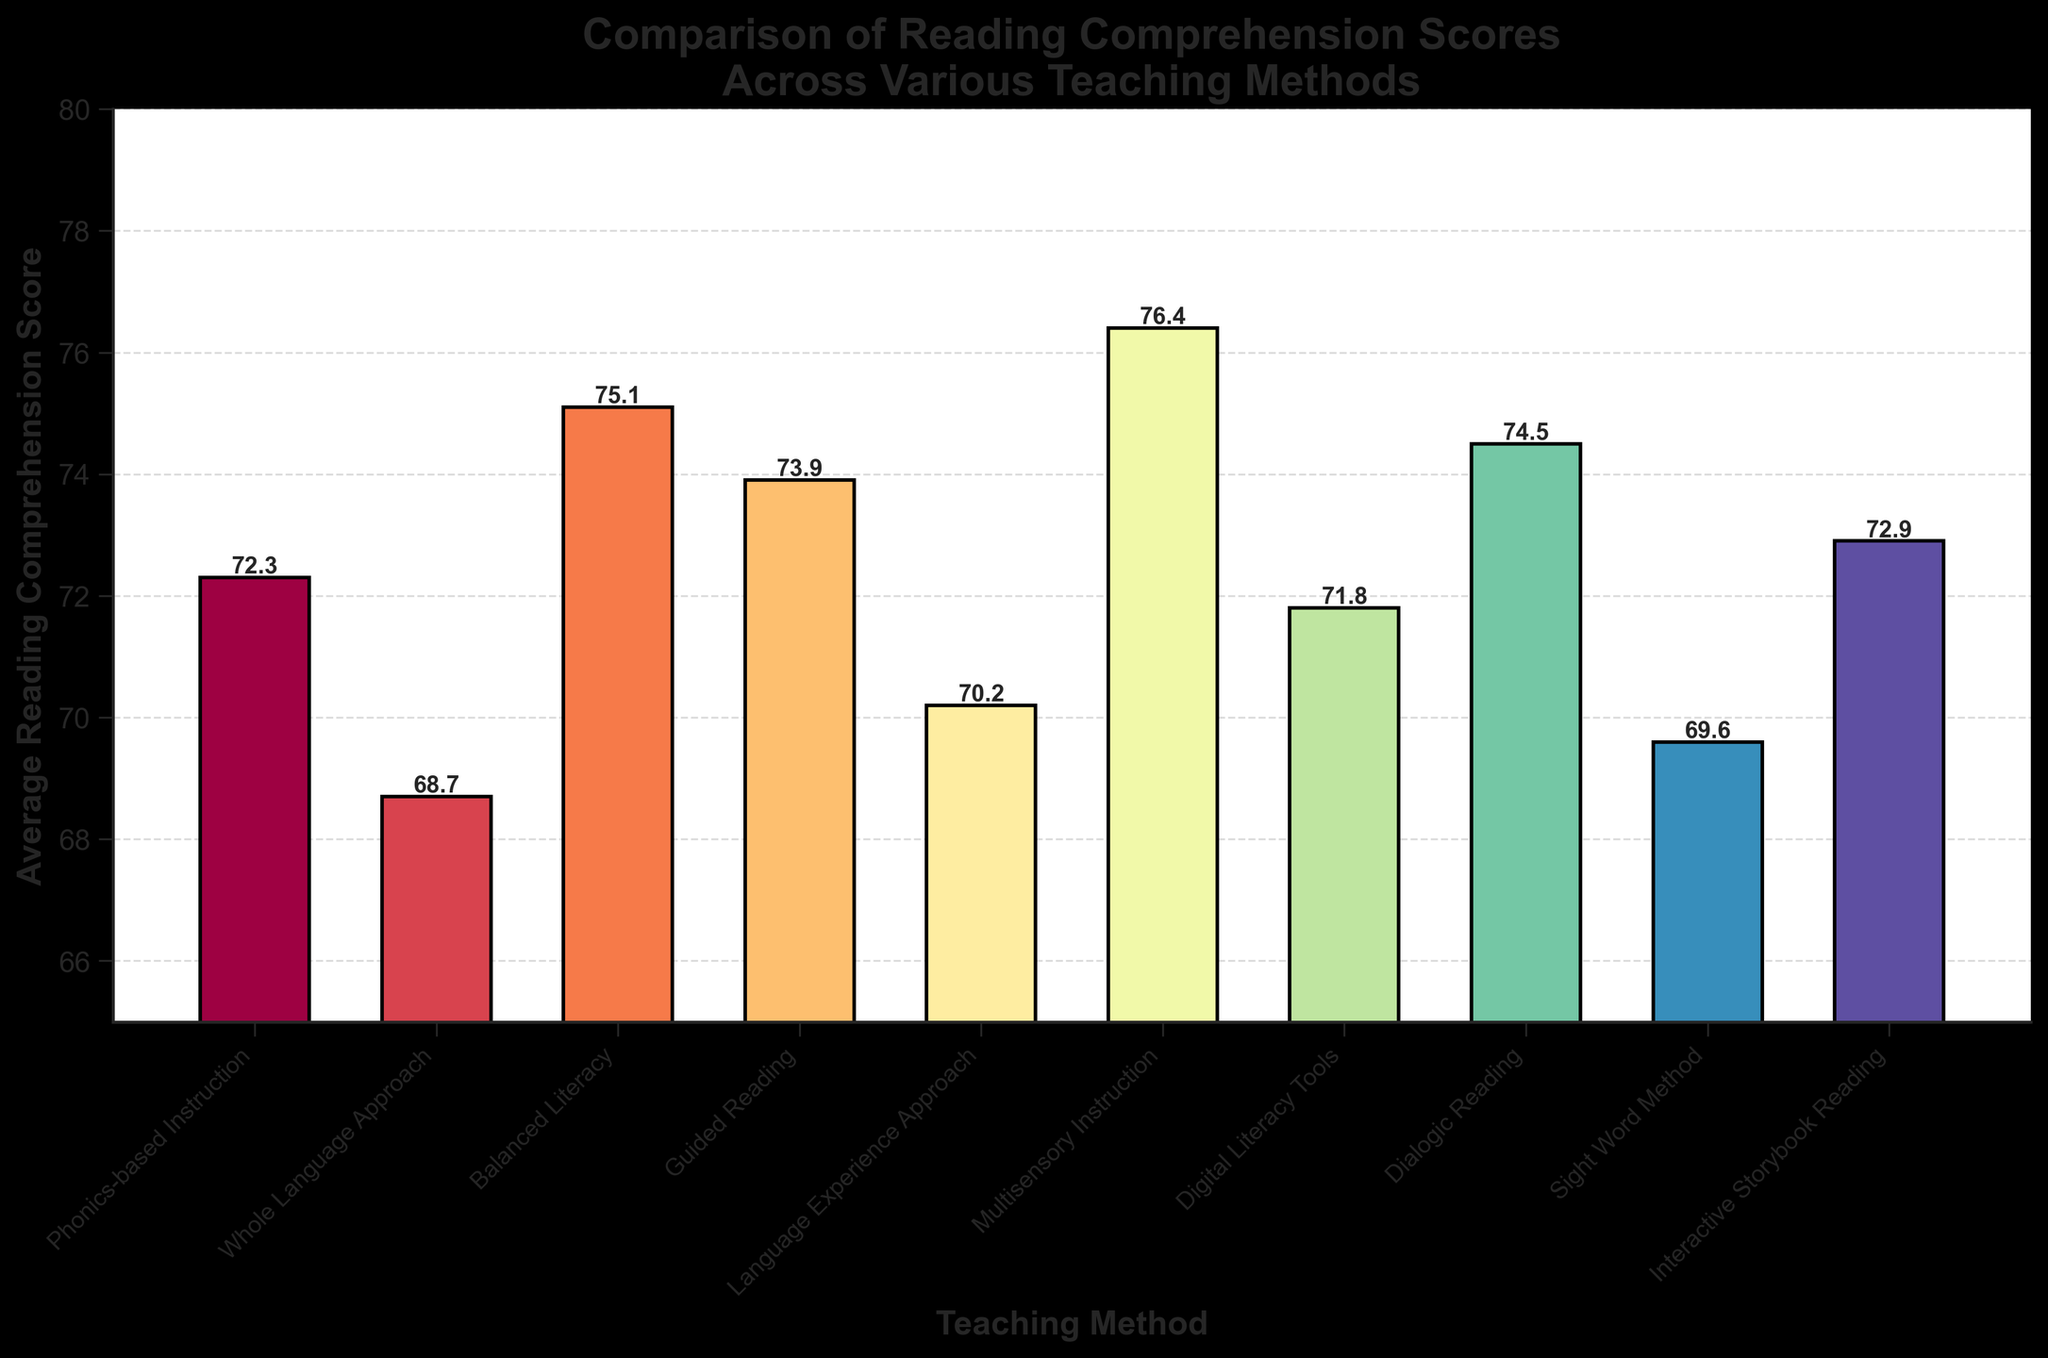Which teaching method has the highest average reading comprehension score? Look for the tallest bar in the bar chart, which represents the highest score. The corresponding label at its base is the teaching method with the highest score.
Answer: Multisensory Instruction What is the difference in average reading comprehension scores between Phonics-based Instruction and Whole Language Approach? Find the heights of the bars for Phonics-based Instruction and Whole Language Approach, then subtract the lower value (68.7) from the higher value (72.3) to get the difference.
Answer: 3.6 Which two teaching methods have an average reading comprehension score above 75? Identify and list the bars taller than 75. These represent teaching methods with scores above 75.
Answer: Balanced Literacy and Multisensory Instruction How many teaching methods have an average score below 70? Identify and count the bars that are below the 70 mark on the y-axis.
Answer: Three (Whole Language Approach, Language Experience Approach, Sight Word Method) Which teaching method has a score closest to 73? Identify the bars and their heights, then find the bar whose score is nearest to 73 by comparing their absolute differences to 73.
Answer: Guided Reading (73.9) Is there any teaching method that has an average score exactly at the midpoint between 68 and 78? Calculate the midpoint (average) between 68 and 78, which is (68+78) / 2 = 73, then check if any bar has this value as its height.
Answer: No Among Guided Reading, Digital Literacy Tools, and Dialogic Reading, which method has the highest score and what is the score? Compare the heights of the bars for Guided Reading, Digital Literacy Tools, and Dialogic Reading, and identify the highest one.
Answer: Dialogic Reading, 74.5 